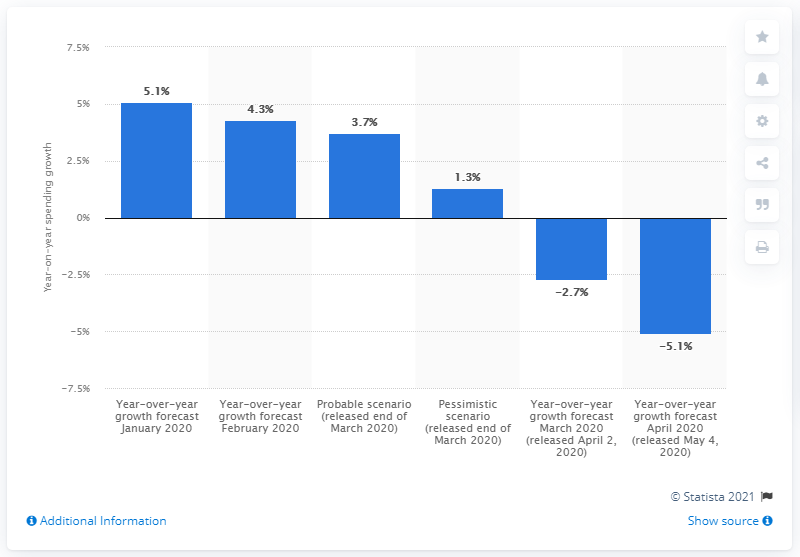Indicate a few pertinent items in this graphic. The current forecast for the global IT industry declining by X% in 2020 compared to the previous year. The expected scenario for IT spending growth in 2024 is projected to be 3.7% higher than in 2019. The pessimistic scenario for IT spending in 2020 is expected to be 1.3. 